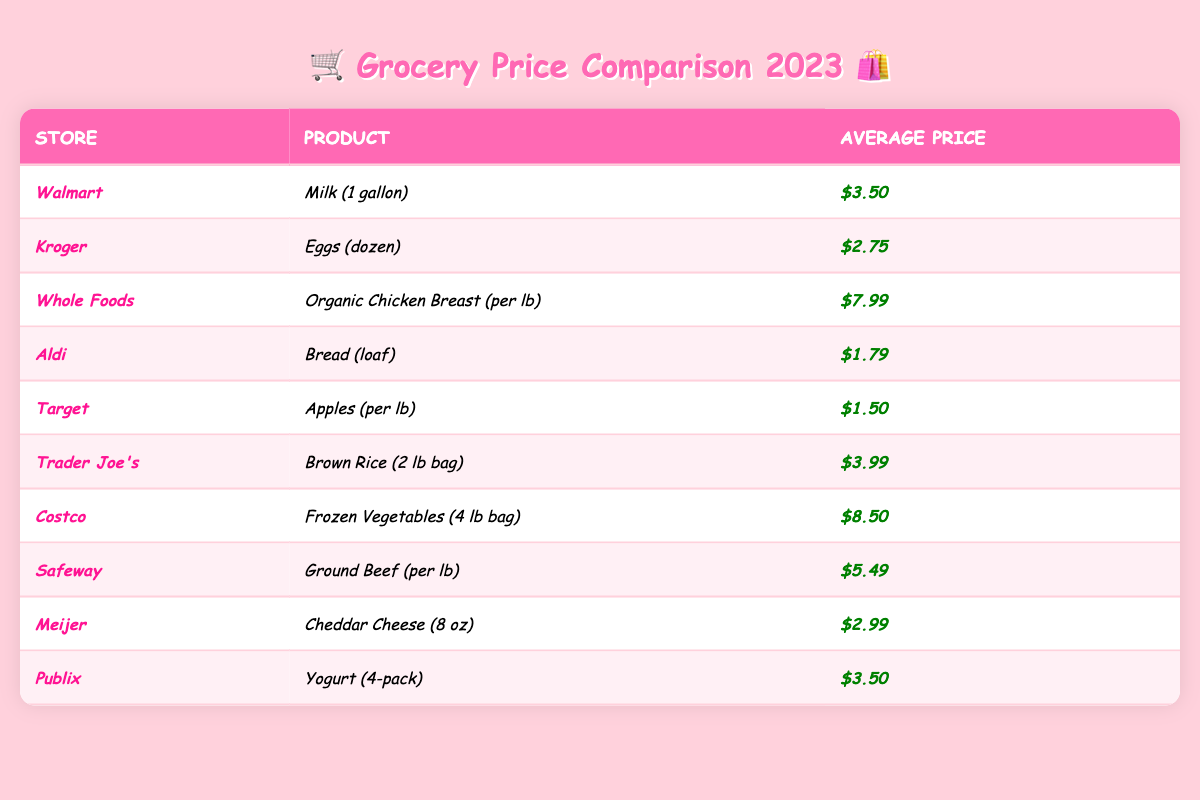What store has the cheapest milk? By looking at the average prices shown in the table, Walmart sells milk (1 gallon) for $3.50, which is the only listing for milk, making it the cheapest by default.
Answer: Walmart Which product is the most expensive, and where can I find it? The product with the highest average price is Organic Chicken Breast at Whole Foods, priced at $7.99.
Answer: Organic Chicken Breast at Whole Foods Is buying bread at Aldi cheaper than buying yogurt at Publix? Aldi's bread (loaf) is priced at $1.79, while Publix's yogurt (4-pack) costs $3.50. Since $1.79 is less than $3.50, bread at Aldi is cheaper.
Answer: Yes How much more does a bag of frozen vegetables at Costco cost than a loaf of bread at Aldi? The bag of frozen vegetables (4 lb) at Costco costs $8.50, while the loaf of bread at Aldi costs $1.79. The difference is calculated as $8.50 - $1.79 = $6.71.
Answer: $6.71 What is the average price of eggs and cheddar cheese together? The average price of eggs (dozen) at Kroger is $2.75, and cheddar cheese (8 oz) at Meijer is $2.99. Adding these prices gives $2.75 + $2.99 = $5.74. To find the average, divide by 2: $5.74 / 2 = $2.87.
Answer: $2.87 Do both Target and Aldi sell fruits? Target sells apples (per lb), while Aldi sells bread (loaf). Neither of these is a fruit in Aldi's listing, meaning only Target has a fruit.
Answer: No Which store has the highest price difference between its most expensive and least expensive products? Whole Foods' Organic Chicken Breast ($7.99) is the most expensive, while Kroger's Eggs ($2.75) are the least expensive. The difference is $7.99 - $2.75 = $5.24. Costco's prices also have a large difference: $8.50 (Frozen Vegetables) - $1.79 (Bread) = $6.71. The largest difference is with Costco.
Answer: Costco How many of the stores offer products that cost less than $3? By reviewing the table, we see that Aldi ($1.79), Target ($1.50), Kroger ($2.75), and Meijer ($2.99) have products priced less than $3, totaling four stores.
Answer: 4 stores 